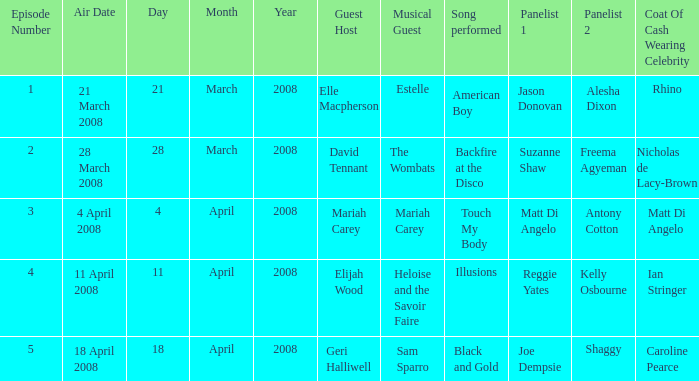Name the total number of coat of cash wearing celebrity where panelists are matt di angelo and antony cotton 1.0. 